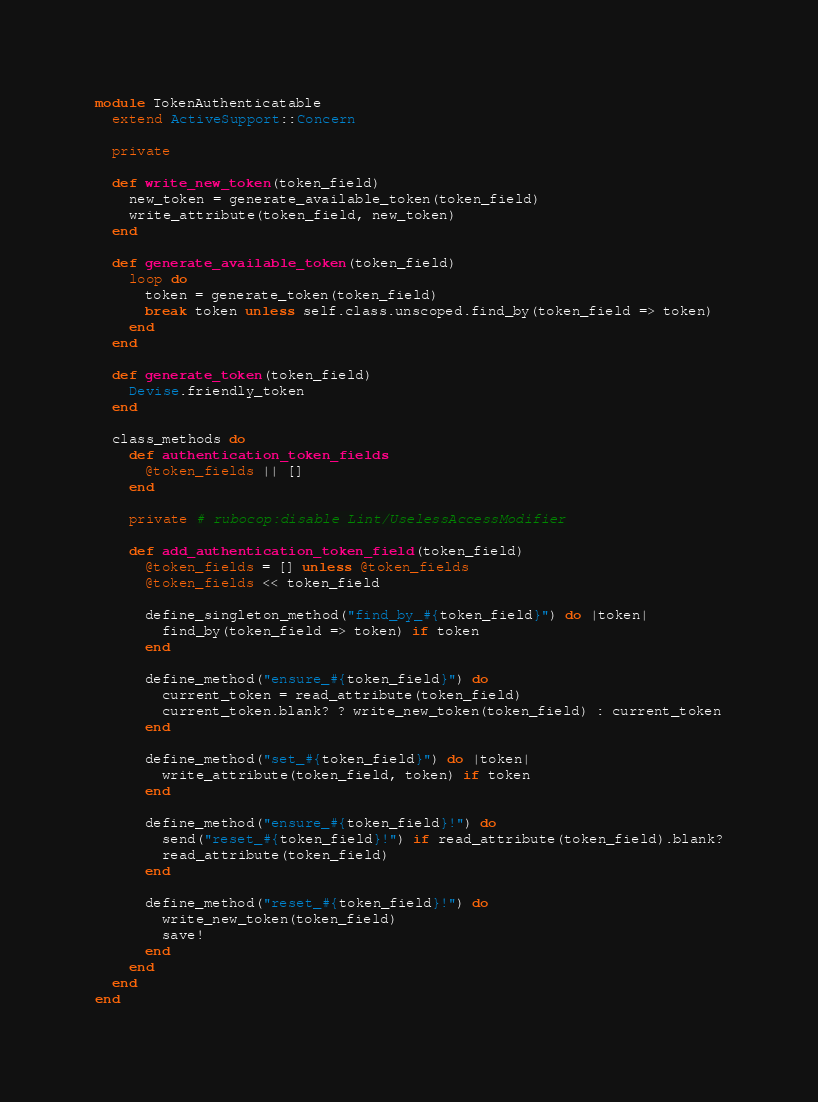<code> <loc_0><loc_0><loc_500><loc_500><_Ruby_>module TokenAuthenticatable
  extend ActiveSupport::Concern

  private

  def write_new_token(token_field)
    new_token = generate_available_token(token_field)
    write_attribute(token_field, new_token)
  end

  def generate_available_token(token_field)
    loop do
      token = generate_token(token_field)
      break token unless self.class.unscoped.find_by(token_field => token)
    end
  end

  def generate_token(token_field)
    Devise.friendly_token
  end

  class_methods do
    def authentication_token_fields
      @token_fields || []
    end

    private # rubocop:disable Lint/UselessAccessModifier

    def add_authentication_token_field(token_field)
      @token_fields = [] unless @token_fields
      @token_fields << token_field

      define_singleton_method("find_by_#{token_field}") do |token|
        find_by(token_field => token) if token
      end

      define_method("ensure_#{token_field}") do
        current_token = read_attribute(token_field)
        current_token.blank? ? write_new_token(token_field) : current_token
      end

      define_method("set_#{token_field}") do |token|
        write_attribute(token_field, token) if token
      end

      define_method("ensure_#{token_field}!") do
        send("reset_#{token_field}!") if read_attribute(token_field).blank?
        read_attribute(token_field)
      end

      define_method("reset_#{token_field}!") do
        write_new_token(token_field)
        save!
      end
    end
  end
end
</code> 